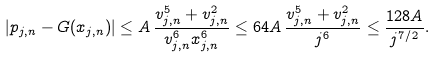Convert formula to latex. <formula><loc_0><loc_0><loc_500><loc_500>| p _ { j , n } - G ( x _ { j , n } ) | \leq A \, \frac { v _ { j , n } ^ { 5 } + v _ { j , n } ^ { 2 } } { v _ { j , n } ^ { 6 } x _ { j , n } ^ { 6 } } \leq 6 4 A \, \frac { v _ { j , n } ^ { 5 } + v _ { j , n } ^ { 2 } } { j ^ { 6 } } \leq \frac { 1 2 8 A } { j ^ { 7 / 2 } } .</formula> 